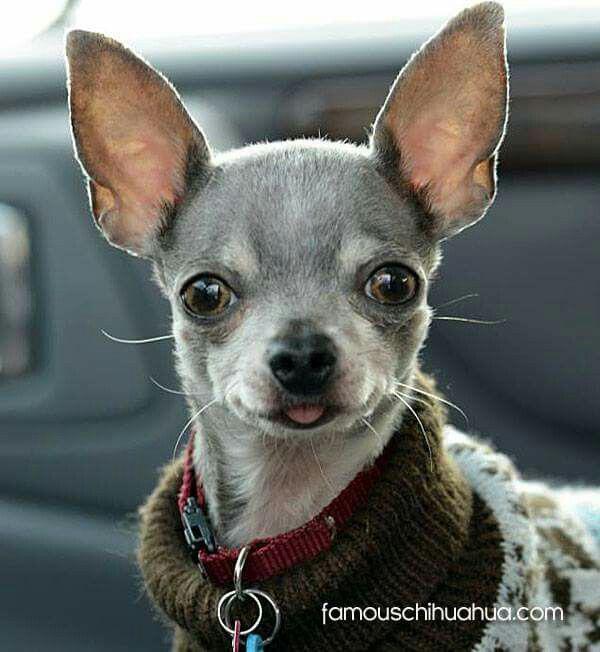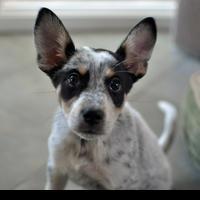The first image is the image on the left, the second image is the image on the right. Given the left and right images, does the statement "One of the dogs is sticking it's tongue out of a closed mouth." hold true? Answer yes or no. Yes. 